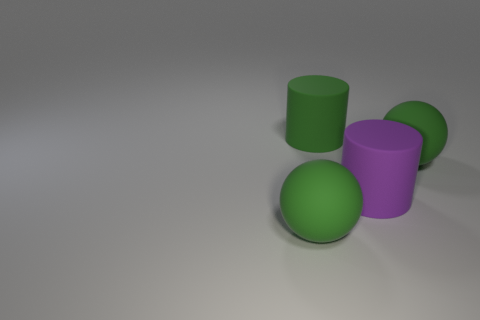There is a big purple object; is it the same shape as the green matte thing that is on the left side of the large green cylinder?
Offer a terse response. No. There is a big thing that is behind the big green ball behind the rubber ball that is to the left of the purple rubber cylinder; what is its shape?
Offer a very short reply. Cylinder. What number of other things are there of the same material as the purple cylinder
Keep it short and to the point. 3. How many things are rubber things on the right side of the large green cylinder or purple rubber things?
Offer a very short reply. 2. There is a big green object that is in front of the matte thing on the right side of the purple matte cylinder; what is its shape?
Give a very brief answer. Sphere. Does the big green matte thing that is in front of the purple rubber thing have the same shape as the big purple rubber thing?
Ensure brevity in your answer.  No. What is the color of the large matte thing that is in front of the big purple matte thing?
Your answer should be very brief. Green. What number of cubes are brown matte objects or green things?
Your answer should be compact. 0. There is a green matte object in front of the rubber object on the right side of the big purple cylinder; how big is it?
Your response must be concise. Large. How many purple rubber things are on the left side of the large purple cylinder?
Provide a short and direct response. 0. 